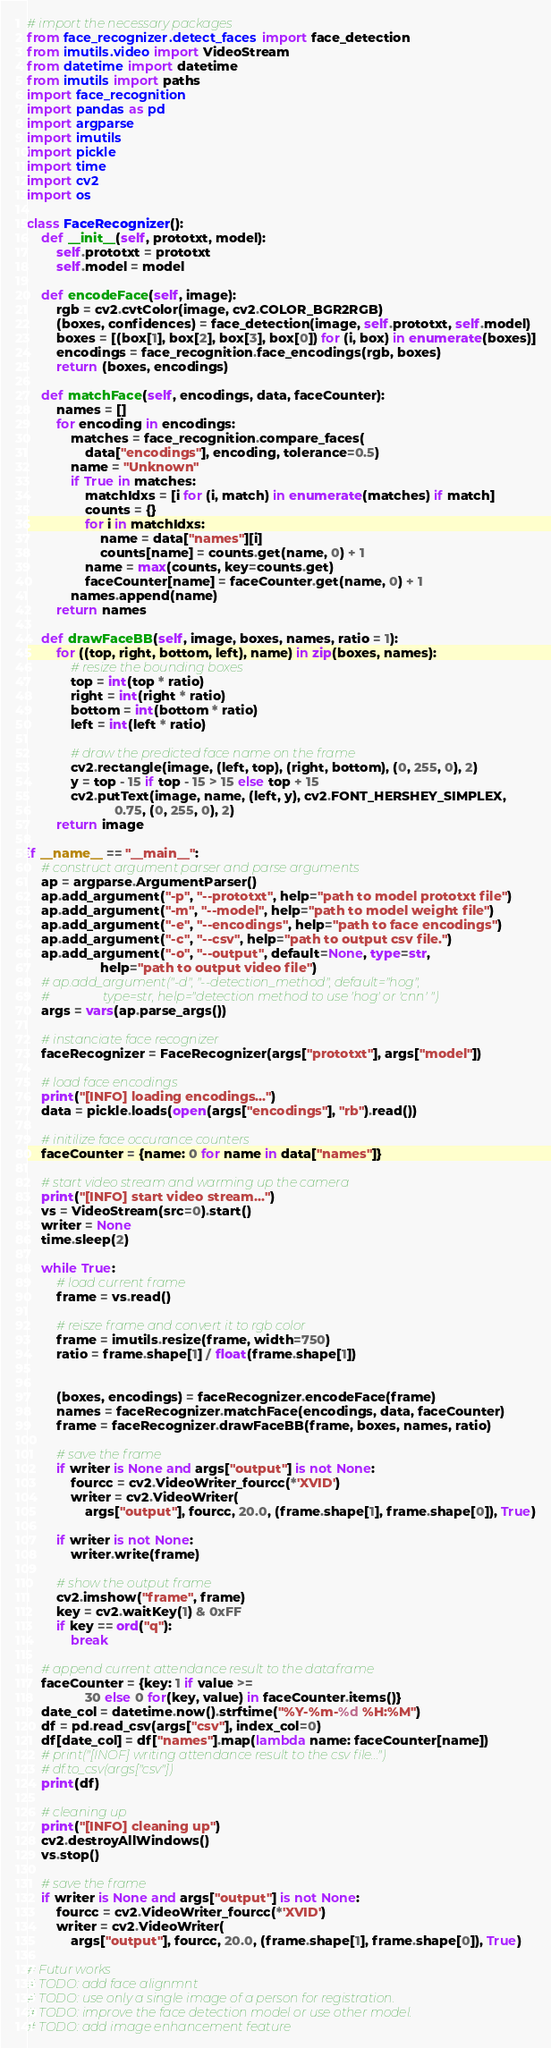<code> <loc_0><loc_0><loc_500><loc_500><_Python_># import the necessary packages
from face_recognizer.detect_faces import face_detection
from imutils.video import VideoStream
from datetime import datetime
from imutils import paths
import face_recognition
import pandas as pd
import argparse
import imutils
import pickle
import time
import cv2
import os

class FaceRecognizer():
    def __init__(self, prototxt, model):
        self.prototxt = prototxt
        self.model = model

    def encodeFace(self, image):
        rgb = cv2.cvtColor(image, cv2.COLOR_BGR2RGB)
        (boxes, confidences) = face_detection(image, self.prototxt, self.model)
        boxes = [(box[1], box[2], box[3], box[0]) for (i, box) in enumerate(boxes)]
        encodings = face_recognition.face_encodings(rgb, boxes)
        return (boxes, encodings)

    def matchFace(self, encodings, data, faceCounter):
        names = []
        for encoding in encodings:
            matches = face_recognition.compare_faces(
                data["encodings"], encoding, tolerance=0.5)
            name = "Unknown"
            if True in matches:
                matchIdxs = [i for (i, match) in enumerate(matches) if match]
                counts = {}
                for i in matchIdxs:
                    name = data["names"][i]
                    counts[name] = counts.get(name, 0) + 1
                name = max(counts, key=counts.get)
                faceCounter[name] = faceCounter.get(name, 0) + 1
            names.append(name)
        return names

    def drawFaceBB(self, image, boxes, names, ratio = 1):
        for ((top, right, bottom, left), name) in zip(boxes, names):
            # resize the bounding boxes
            top = int(top * ratio)
            right = int(right * ratio)
            bottom = int(bottom * ratio)
            left = int(left * ratio)

            # draw the predicted face name on the frame
            cv2.rectangle(image, (left, top), (right, bottom), (0, 255, 0), 2)
            y = top - 15 if top - 15 > 15 else top + 15
            cv2.putText(image, name, (left, y), cv2.FONT_HERSHEY_SIMPLEX,
                        0.75, (0, 255, 0), 2)
        return image

if __name__ == "__main__":
    # construct argument parser and parse arguments
    ap = argparse.ArgumentParser()
    ap.add_argument("-p", "--prototxt", help="path to model prototxt file")
    ap.add_argument("-m", "--model", help="path to model weight file")
    ap.add_argument("-e", "--encodings", help="path to face encodings")
    ap.add_argument("-c", "--csv", help="path to output csv file.")
    ap.add_argument("-o", "--output", default=None, type=str,
                    help="path to output video file")
    # ap.add_argument("-d", "--detection_method", default="hog",
    #                 type=str, help="detection method to use 'hog' or 'cnn' ")
    args = vars(ap.parse_args())

    # instanciate face recognizer
    faceRecognizer = FaceRecognizer(args["prototxt"], args["model"])

    # load face encodings
    print("[INFO] loading encodings...")
    data = pickle.loads(open(args["encodings"], "rb").read())

    # initilize face occurance counters
    faceCounter = {name: 0 for name in data["names"]}

    # start video stream and warming up the camera
    print("[INFO] start video stream...")
    vs = VideoStream(src=0).start()
    writer = None
    time.sleep(2)

    while True:
        # load current frame 
        frame = vs.read()

        # reisze frame and convert it to rgb color
        frame = imutils.resize(frame, width=750)
        ratio = frame.shape[1] / float(frame.shape[1])


        (boxes, encodings) = faceRecognizer.encodeFace(frame)
        names = faceRecognizer.matchFace(encodings, data, faceCounter)
        frame = faceRecognizer.drawFaceBB(frame, boxes, names, ratio)

        # save the frame
        if writer is None and args["output"] is not None:
            fourcc = cv2.VideoWriter_fourcc(*'XVID')
            writer = cv2.VideoWriter(
                args["output"], fourcc, 20.0, (frame.shape[1], frame.shape[0]), True)

        if writer is not None:
            writer.write(frame)

        # show the output frame
        cv2.imshow("frame", frame)
        key = cv2.waitKey(1) & 0xFF
        if key == ord("q"):
            break

    # append current attendance result to the dataframe
    faceCounter = {key: 1 if value >=
                30 else 0 for(key, value) in faceCounter.items()}
    date_col = datetime.now().strftime("%Y-%m-%d %H:%M")
    df = pd.read_csv(args["csv"], index_col=0)
    df[date_col] = df["names"].map(lambda name: faceCounter[name])
    # print("[INOF] writing attendance result to the csv file...")
    # df.to_csv(args["csv"])
    print(df)

    # cleaning up
    print("[INFO] cleaning up")
    cv2.destroyAllWindows()
    vs.stop()

    # save the frame
    if writer is None and args["output"] is not None:
        fourcc = cv2.VideoWriter_fourcc(*'XVID')
        writer = cv2.VideoWriter(
            args["output"], fourcc, 20.0, (frame.shape[1], frame.shape[0]), True)

# Futur works
# TODO: add face alignmnt
# TODO: use only a single image of a person for registration.
# TODO: improve the face detection model or use other model.
# TODO: add image enhancement feature
</code> 